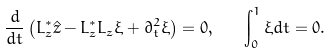<formula> <loc_0><loc_0><loc_500><loc_500>\frac { d } { d t } \left ( L ^ { * } _ { z } \hat { z } - L _ { z } ^ { * } L _ { z } \xi + \partial _ { t } ^ { 2 } \xi \right ) = 0 , \quad \int _ { 0 } ^ { 1 } \xi d t = 0 .</formula> 